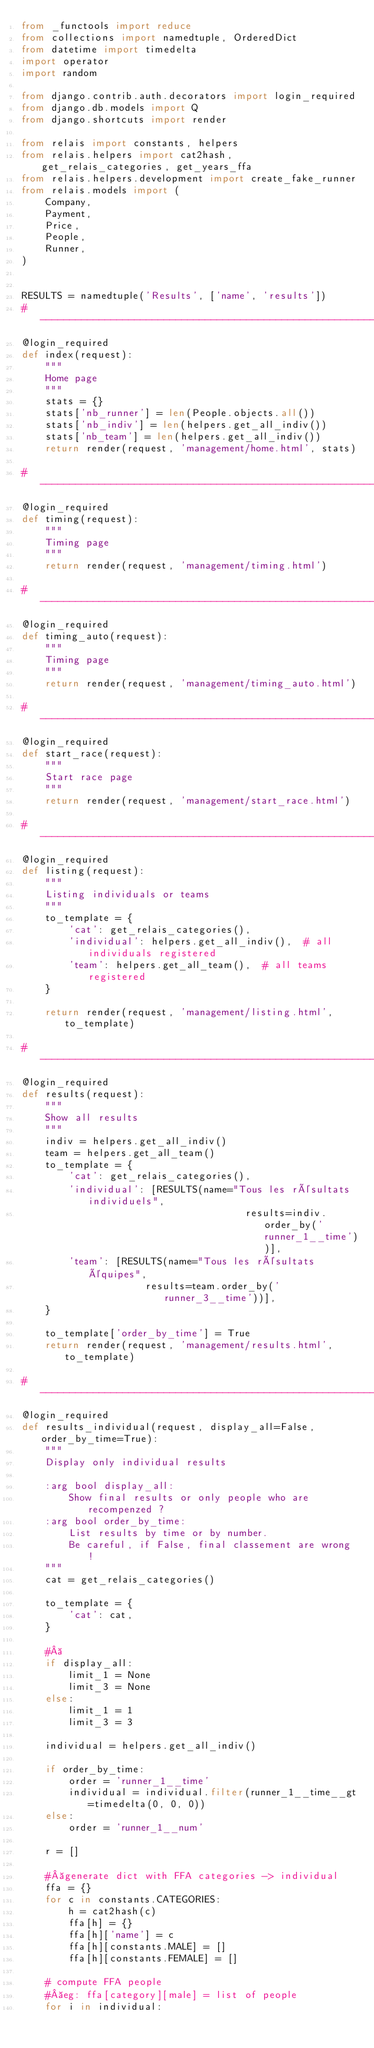<code> <loc_0><loc_0><loc_500><loc_500><_Python_>from _functools import reduce
from collections import namedtuple, OrderedDict
from datetime import timedelta
import operator
import random

from django.contrib.auth.decorators import login_required
from django.db.models import Q
from django.shortcuts import render

from relais import constants, helpers
from relais.helpers import cat2hash, get_relais_categories, get_years_ffa
from relais.helpers.development import create_fake_runner
from relais.models import (
    Company,
    Payment,
    Price,
    People,
    Runner,
)


RESULTS = namedtuple('Results', ['name', 'results'])
#------------------------------------------------------------------------------
@login_required
def index(request):
    """
    Home page
    """
    stats = {}
    stats['nb_runner'] = len(People.objects.all())
    stats['nb_indiv'] = len(helpers.get_all_indiv())
    stats['nb_team'] = len(helpers.get_all_indiv())
    return render(request, 'management/home.html', stats)

#------------------------------------------------------------------------------
@login_required
def timing(request):
    """
    Timing page
    """
    return render(request, 'management/timing.html')

#------------------------------------------------------------------------------
@login_required
def timing_auto(request):
    """
    Timing page
    """
    return render(request, 'management/timing_auto.html')

#------------------------------------------------------------------------------
@login_required
def start_race(request):
    """
    Start race page
    """
    return render(request, 'management/start_race.html')

#------------------------------------------------------------------------------
@login_required
def listing(request):
    """
    Listing individuals or teams
    """
    to_template = {
        'cat': get_relais_categories(),
        'individual': helpers.get_all_indiv(),  # all individuals registered
        'team': helpers.get_all_team(),  # all teams registered
    }

    return render(request, 'management/listing.html', to_template)

#------------------------------------------------------------------------------
@login_required
def results(request):
    """
    Show all results
    """
    indiv = helpers.get_all_indiv()
    team = helpers.get_all_team()
    to_template = {
        'cat': get_relais_categories(),
        'individual': [RESULTS(name="Tous les résultats individuels",
                                      results=indiv.order_by('runner_1__time'))],
        'team': [RESULTS(name="Tous les résultats équipes",
                     results=team.order_by('runner_3__time'))],
    }

    to_template['order_by_time'] = True
    return render(request, 'management/results.html', to_template)

#------------------------------------------------------------------------------
@login_required
def results_individual(request, display_all=False, order_by_time=True):
    """
    Display only individual results

    :arg bool display_all:
        Show final results or only people who are recompenzed ?
    :arg bool order_by_time:
        List results by time or by number.
        Be careful, if False, final classement are wrong !
    """
    cat = get_relais_categories()

    to_template = {
        'cat': cat,
    }

    # 
    if display_all:
        limit_1 = None
        limit_3 = None
    else:
        limit_1 = 1
        limit_3 = 3

    individual = helpers.get_all_indiv() 

    if order_by_time:
        order = 'runner_1__time'
        individual = individual.filter(runner_1__time__gt=timedelta(0, 0, 0))
    else:
        order = 'runner_1__num'

    r = []

    # generate dict with FFA categories -> individual
    ffa = {}
    for c in constants.CATEGORIES:
        h = cat2hash(c)
        ffa[h] = {}
        ffa[h]['name'] = c
        ffa[h][constants.MALE] = []
        ffa[h][constants.FEMALE] = []

    # compute FFA people
    # eg: ffa[category][male] = list of people
    for i in individual:</code> 